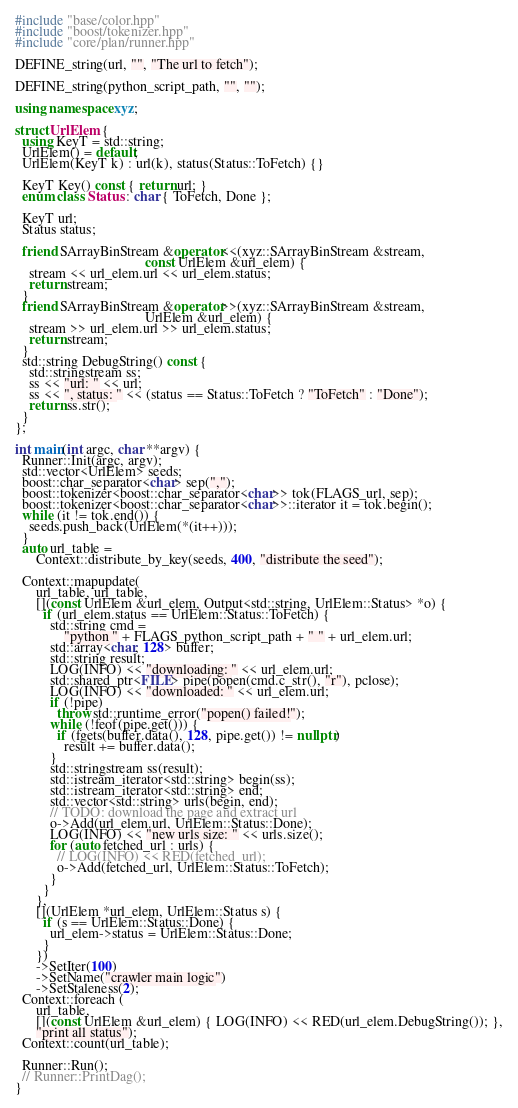<code> <loc_0><loc_0><loc_500><loc_500><_C++_>#include "base/color.hpp"
#include "boost/tokenizer.hpp"
#include "core/plan/runner.hpp"

DEFINE_string(url, "", "The url to fetch");

DEFINE_string(python_script_path, "", "");

using namespace xyz;

struct UrlElem {
  using KeyT = std::string;
  UrlElem() = default;
  UrlElem(KeyT k) : url(k), status(Status::ToFetch) {}

  KeyT Key() const { return url; }
  enum class Status : char { ToFetch, Done };

  KeyT url;
  Status status;

  friend SArrayBinStream &operator<<(xyz::SArrayBinStream &stream,
                                     const UrlElem &url_elem) {
    stream << url_elem.url << url_elem.status;
    return stream;
  }
  friend SArrayBinStream &operator>>(xyz::SArrayBinStream &stream,
                                     UrlElem &url_elem) {
    stream >> url_elem.url >> url_elem.status;
    return stream;
  }
  std::string DebugString() const {
    std::stringstream ss;
    ss << "url: " << url;
    ss << ", status: " << (status == Status::ToFetch ? "ToFetch" : "Done");
    return ss.str();
  }
};

int main(int argc, char **argv) {
  Runner::Init(argc, argv);
  std::vector<UrlElem> seeds;
  boost::char_separator<char> sep(",");
  boost::tokenizer<boost::char_separator<char>> tok(FLAGS_url, sep);
  boost::tokenizer<boost::char_separator<char>>::iterator it = tok.begin();
  while (it != tok.end()) {
    seeds.push_back(UrlElem(*(it++)));
  }
  auto url_table =
      Context::distribute_by_key(seeds, 400, "distribute the seed");

  Context::mapupdate(
      url_table, url_table,
      [](const UrlElem &url_elem, Output<std::string, UrlElem::Status> *o) {
        if (url_elem.status == UrlElem::Status::ToFetch) {
          std::string cmd =
              "python " + FLAGS_python_script_path + " " + url_elem.url;
          std::array<char, 128> buffer;
          std::string result;
          LOG(INFO) << "downloading: " << url_elem.url;
          std::shared_ptr<FILE> pipe(popen(cmd.c_str(), "r"), pclose);
          LOG(INFO) << "downloaded: " << url_elem.url;
          if (!pipe)
            throw std::runtime_error("popen() failed!");
          while (!feof(pipe.get())) {
            if (fgets(buffer.data(), 128, pipe.get()) != nullptr)
              result += buffer.data();
          }
          std::stringstream ss(result);
          std::istream_iterator<std::string> begin(ss);
          std::istream_iterator<std::string> end;
          std::vector<std::string> urls(begin, end);
          // TODO: download the page and extract url
          o->Add(url_elem.url, UrlElem::Status::Done);
          LOG(INFO) << "new urls size: " << urls.size();
          for (auto fetched_url : urls) {
            // LOG(INFO) << RED(fetched_url);
            o->Add(fetched_url, UrlElem::Status::ToFetch);
          }
        }
      },
      [](UrlElem *url_elem, UrlElem::Status s) {
        if (s == UrlElem::Status::Done) {
          url_elem->status = UrlElem::Status::Done;
        }
      })
      ->SetIter(100)
      ->SetName("crawler main logic")
      ->SetStaleness(2);
  Context::foreach (
      url_table,
      [](const UrlElem &url_elem) { LOG(INFO) << RED(url_elem.DebugString()); },
      "print all status");
  Context::count(url_table);

  Runner::Run();
  // Runner::PrintDag();
}
</code> 